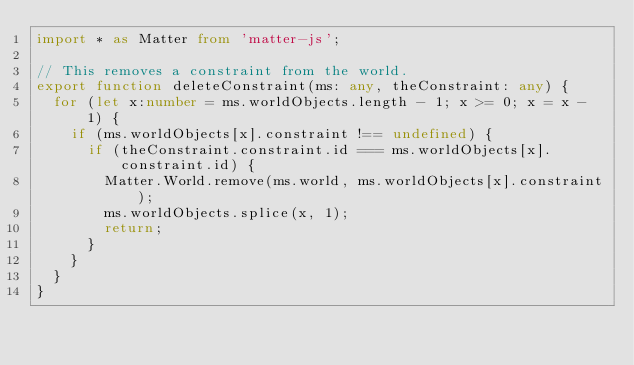Convert code to text. <code><loc_0><loc_0><loc_500><loc_500><_TypeScript_>import * as Matter from 'matter-js';

// This removes a constraint from the world.
export function deleteConstraint(ms: any, theConstraint: any) {
  for (let x:number = ms.worldObjects.length - 1; x >= 0; x = x - 1) {
    if (ms.worldObjects[x].constraint !== undefined) {
      if (theConstraint.constraint.id === ms.worldObjects[x].constraint.id) {
        Matter.World.remove(ms.world, ms.worldObjects[x].constraint);
        ms.worldObjects.splice(x, 1);
        return;
      }
    }
  }
}
</code> 